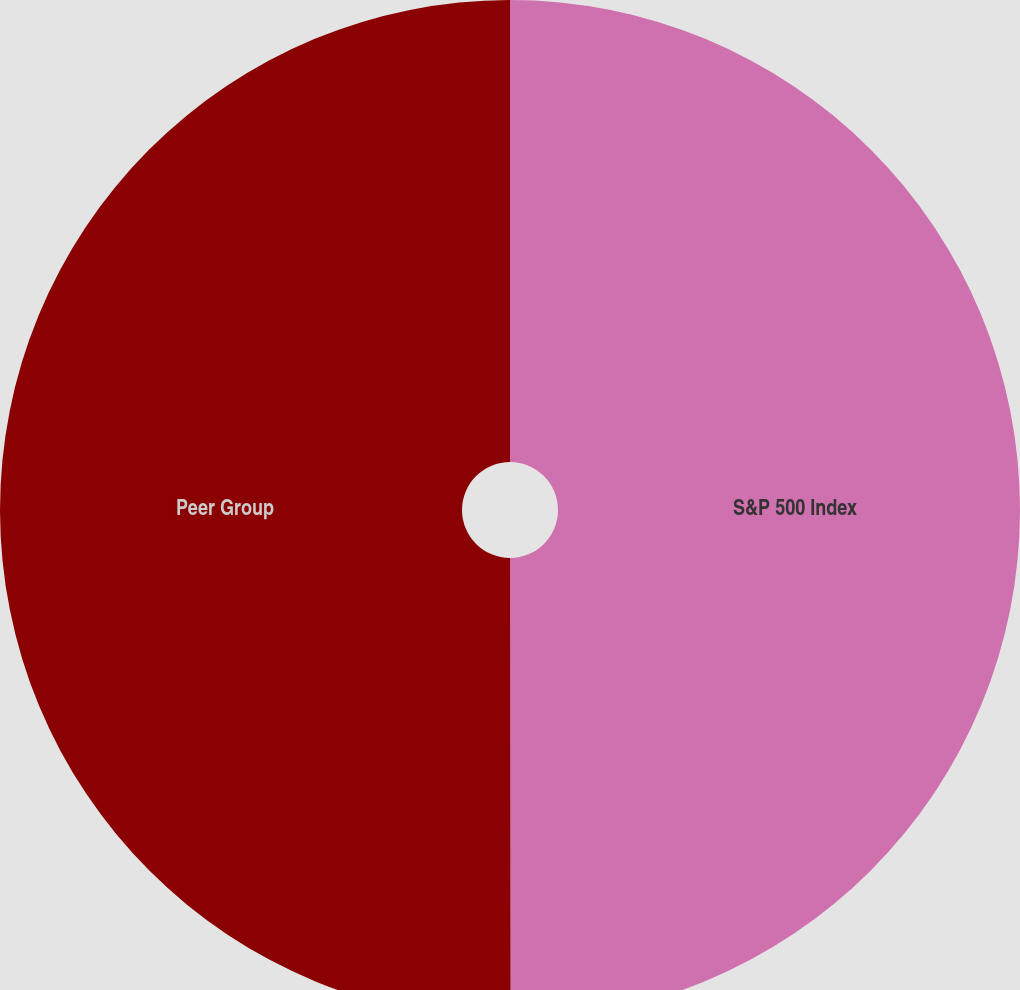Convert chart. <chart><loc_0><loc_0><loc_500><loc_500><pie_chart><fcel>S&P 500 Index<fcel>Peer Group<nl><fcel>49.98%<fcel>50.02%<nl></chart> 